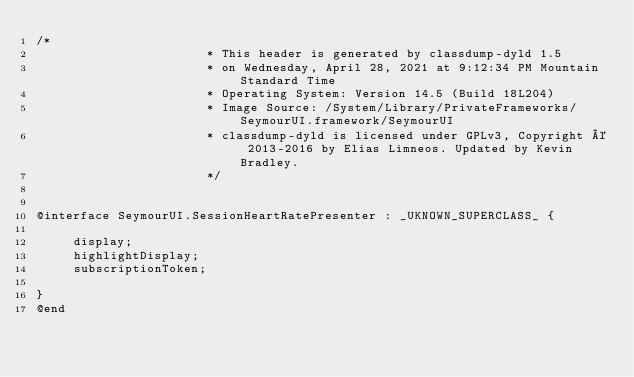Convert code to text. <code><loc_0><loc_0><loc_500><loc_500><_C_>/*
                       * This header is generated by classdump-dyld 1.5
                       * on Wednesday, April 28, 2021 at 9:12:34 PM Mountain Standard Time
                       * Operating System: Version 14.5 (Build 18L204)
                       * Image Source: /System/Library/PrivateFrameworks/SeymourUI.framework/SeymourUI
                       * classdump-dyld is licensed under GPLv3, Copyright © 2013-2016 by Elias Limneos. Updated by Kevin Bradley.
                       */


@interface SeymourUI.SessionHeartRatePresenter : _UKNOWN_SUPERCLASS_ {

	 display;
	 highlightDisplay;
	 subscriptionToken;

}
@end

</code> 